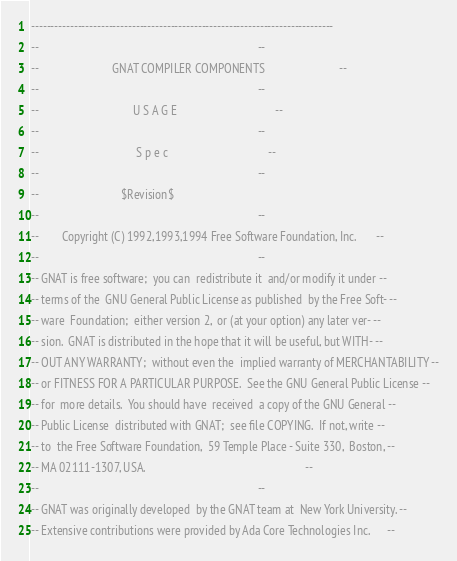Convert code to text. <code><loc_0><loc_0><loc_500><loc_500><_Ada_>------------------------------------------------------------------------------
--                                                                          --
--                         GNAT COMPILER COMPONENTS                         --
--                                                                          --
--                                U S A G E                                 --
--                                                                          --
--                                 S p e c                                  --
--                                                                          --
--                            $Revision$
--                                                                          --
--        Copyright (C) 1992,1993,1994 Free Software Foundation, Inc.       --
--                                                                          --
-- GNAT is free software;  you can  redistribute it  and/or modify it under --
-- terms of the  GNU General Public License as published  by the Free Soft- --
-- ware  Foundation;  either version 2,  or (at your option) any later ver- --
-- sion.  GNAT is distributed in the hope that it will be useful, but WITH- --
-- OUT ANY WARRANTY;  without even the  implied warranty of MERCHANTABILITY --
-- or FITNESS FOR A PARTICULAR PURPOSE.  See the GNU General Public License --
-- for  more details.  You should have  received  a copy of the GNU General --
-- Public License  distributed with GNAT;  see file COPYING.  If not, write --
-- to  the Free Software Foundation,  59 Temple Place - Suite 330,  Boston, --
-- MA 02111-1307, USA.                                                      --
--                                                                          --
-- GNAT was originally developed  by the GNAT team at  New York University. --
-- Extensive contributions were provided by Ada Core Technologies Inc.      --</code> 